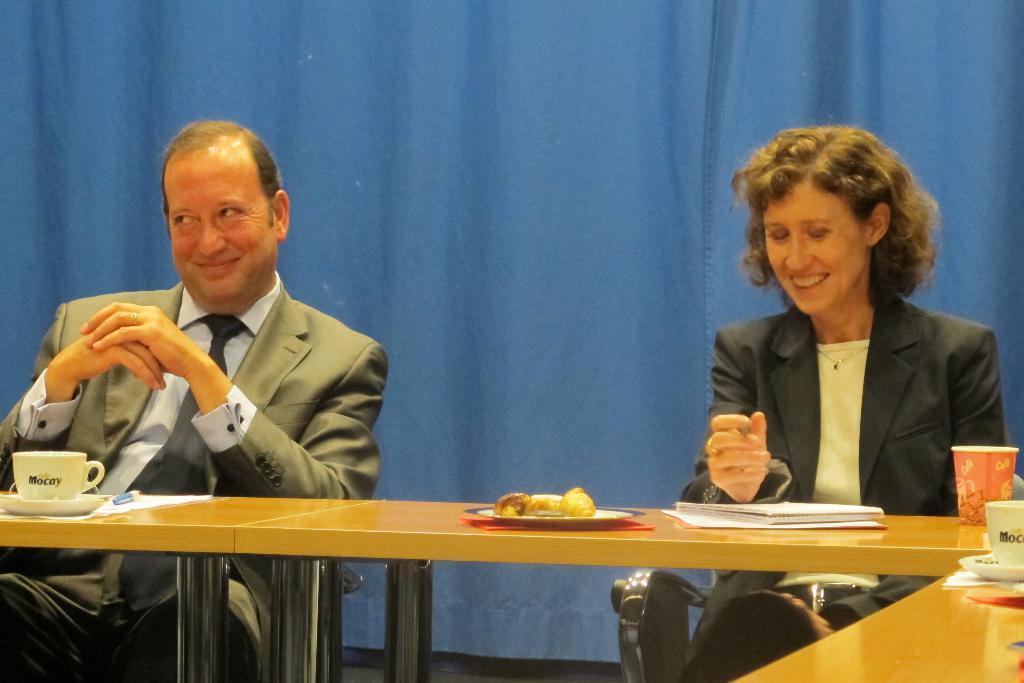Can you describe this image briefly? In this picture we can see a man and a woman sitting on chairs and smiling and in front of them on tables we can see cups, saucers, papers, book, pen, plate, glass and some objects and in the background we can see a blue cloth. 